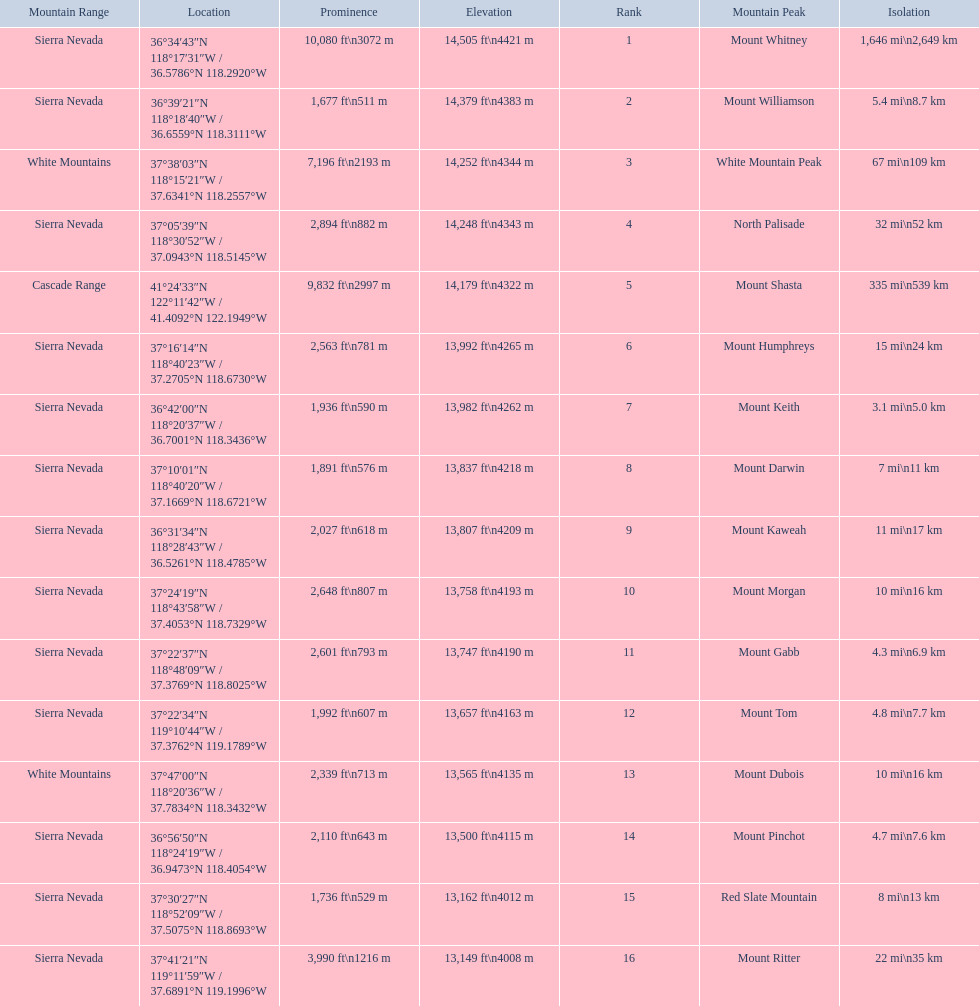What are the peaks in california? Mount Whitney, Mount Williamson, White Mountain Peak, North Palisade, Mount Shasta, Mount Humphreys, Mount Keith, Mount Darwin, Mount Kaweah, Mount Morgan, Mount Gabb, Mount Tom, Mount Dubois, Mount Pinchot, Red Slate Mountain, Mount Ritter. What are the peaks in sierra nevada, california? Mount Whitney, Mount Williamson, North Palisade, Mount Humphreys, Mount Keith, Mount Darwin, Mount Kaweah, Mount Morgan, Mount Gabb, Mount Tom, Mount Pinchot, Red Slate Mountain, Mount Ritter. What are the heights of the peaks in sierra nevada? 14,505 ft\n4421 m, 14,379 ft\n4383 m, 14,248 ft\n4343 m, 13,992 ft\n4265 m, 13,982 ft\n4262 m, 13,837 ft\n4218 m, 13,807 ft\n4209 m, 13,758 ft\n4193 m, 13,747 ft\n4190 m, 13,657 ft\n4163 m, 13,500 ft\n4115 m, 13,162 ft\n4012 m, 13,149 ft\n4008 m. Which is the highest? Mount Whitney. 